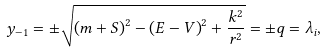Convert formula to latex. <formula><loc_0><loc_0><loc_500><loc_500>y _ { - 1 } = \pm \sqrt { \left ( m + S \right ) ^ { 2 } - \left ( E - V \right ) ^ { 2 } + \frac { k ^ { 2 } } { r ^ { 2 } } } = \pm q = \lambda _ { i } ,</formula> 